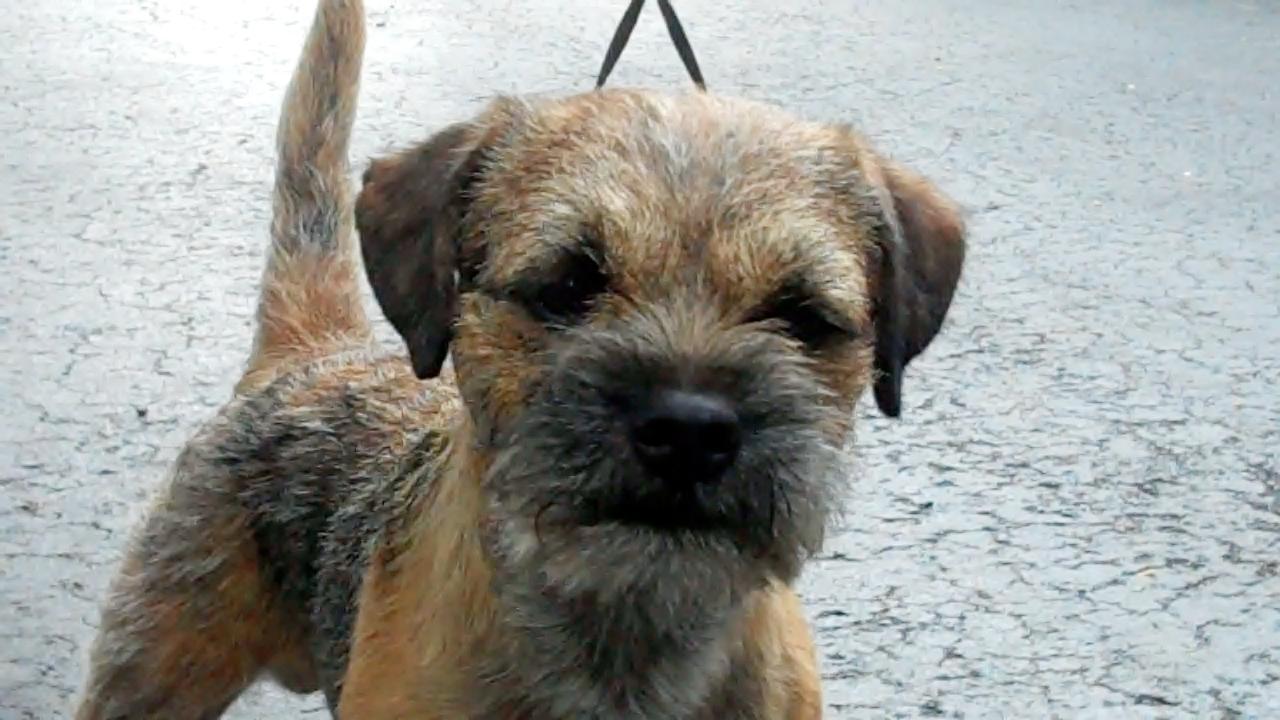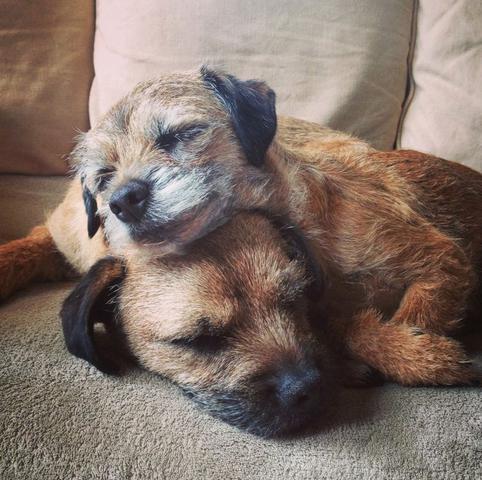The first image is the image on the left, the second image is the image on the right. Analyze the images presented: Is the assertion "In the image to the right, there is but one dog." valid? Answer yes or no. No. 